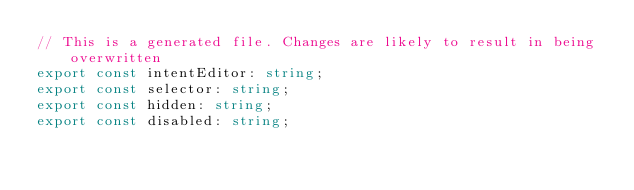Convert code to text. <code><loc_0><loc_0><loc_500><loc_500><_TypeScript_>// This is a generated file. Changes are likely to result in being overwritten
export const intentEditor: string;
export const selector: string;
export const hidden: string;
export const disabled: string;
</code> 